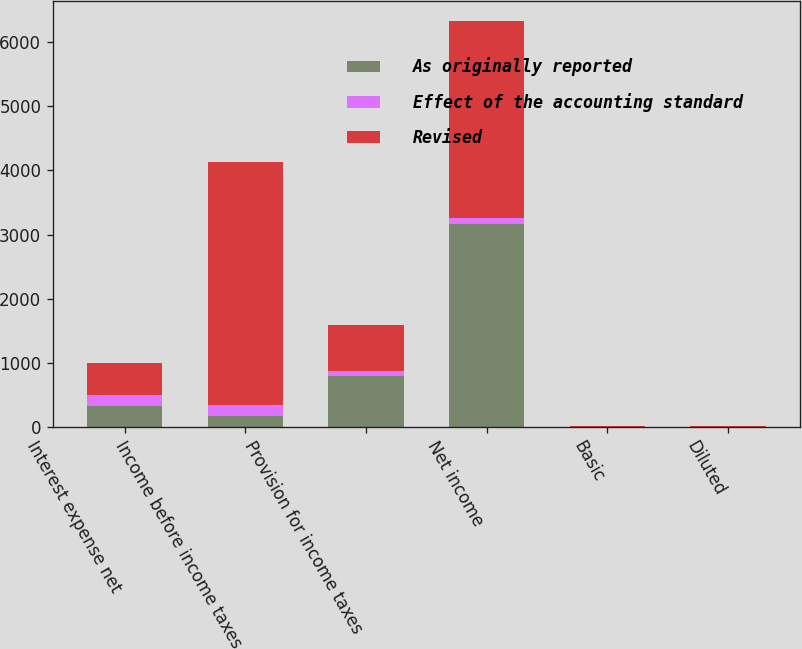Convert chart. <chart><loc_0><loc_0><loc_500><loc_500><stacked_bar_chart><ecel><fcel>Interest expense net<fcel>Income before income taxes<fcel>Provision for income taxes<fcel>Net income<fcel>Basic<fcel>Diluted<nl><fcel>As originally reported<fcel>328<fcel>168<fcel>795<fcel>3166<fcel>2.83<fcel>2.82<nl><fcel>Effect of the accounting standard<fcel>168<fcel>168<fcel>80<fcel>88<fcel>0.07<fcel>0.08<nl><fcel>Revised<fcel>496<fcel>3793<fcel>715<fcel>3078<fcel>2.76<fcel>2.74<nl></chart> 